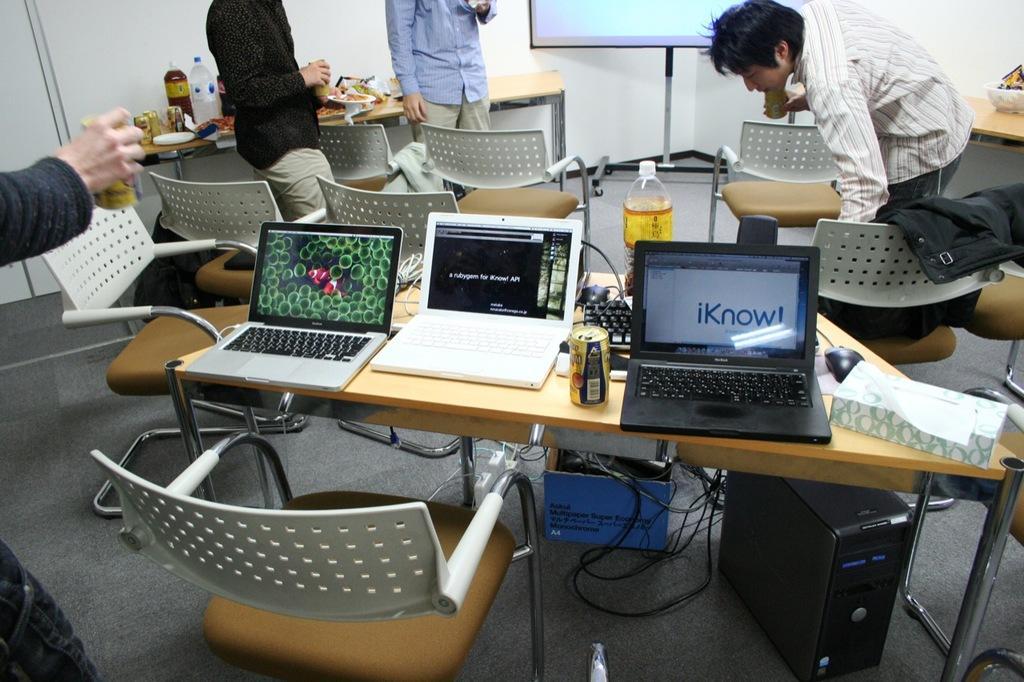How would you summarize this image in a sentence or two? In this picture we can see some chairs around the tables on which there are some laptops, bottles, tin and some things and also we can see four people in the picture and a screen and a key board and some things on the floor. 